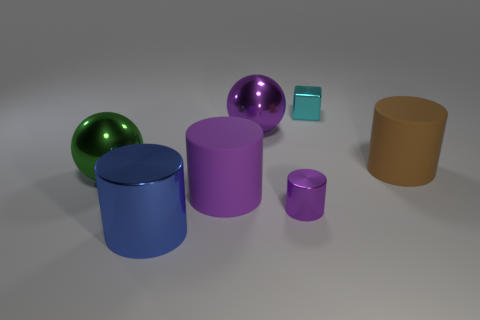How many other things are the same color as the small shiny cylinder?
Provide a succinct answer. 2. What material is the big purple cylinder?
Your answer should be very brief. Rubber. Does the object on the right side of the cyan block have the same size as the small purple cylinder?
Offer a very short reply. No. The other shiny object that is the same shape as the blue object is what size?
Ensure brevity in your answer.  Small. Is the number of large metal cylinders that are left of the tiny cyan block the same as the number of purple matte objects that are in front of the brown rubber cylinder?
Your response must be concise. Yes. What size is the metal cylinder behind the large blue thing?
Keep it short and to the point. Small. Is there any other thing that is the same shape as the cyan shiny object?
Offer a terse response. No. What is the material of the other cylinder that is the same color as the tiny cylinder?
Offer a terse response. Rubber. Are there an equal number of green things that are to the right of the small purple metal object and big brown things?
Offer a very short reply. No. There is a tiny cyan block; are there any big brown objects to the left of it?
Your answer should be very brief. No. 